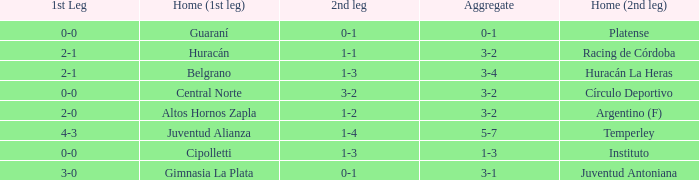Which team played the 2nd leg at home with a tie of 1-1 and scored 3-2 in aggregate? Racing de Córdoba. 